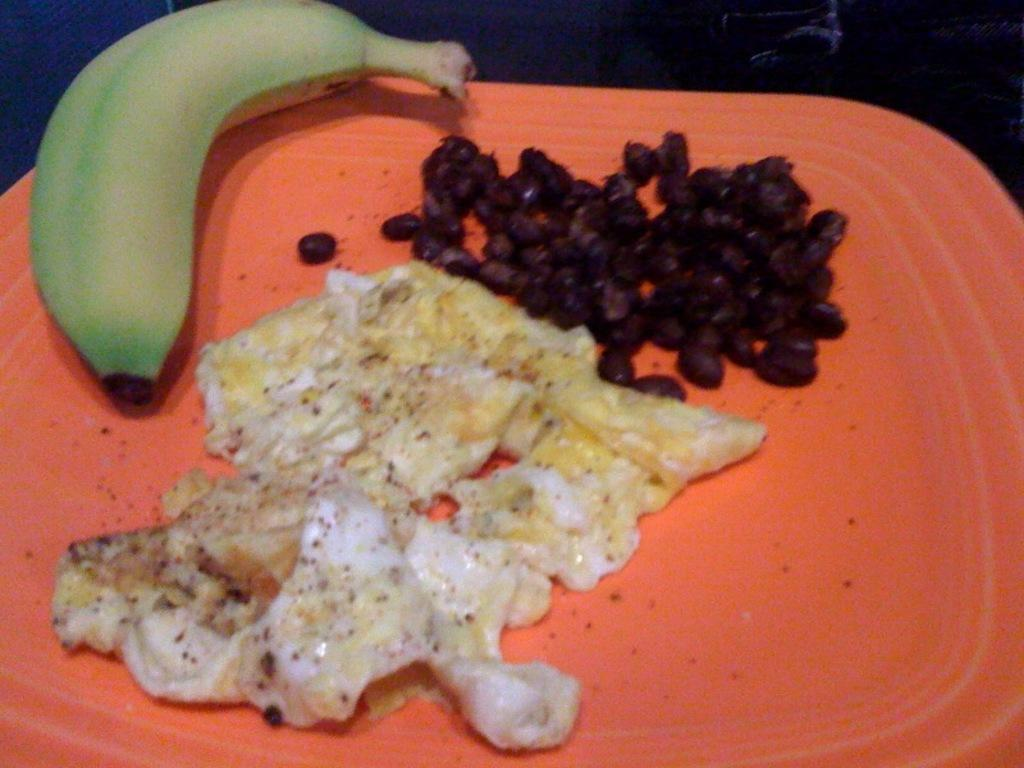What is on the plate that is visible in the image? The plate contains food. Can you identify any specific food item on the plate? Yes, there is a banana on the plate. What type of rock can be seen in the image? There is no rock present in the image; it only features a plate with food and a banana. 